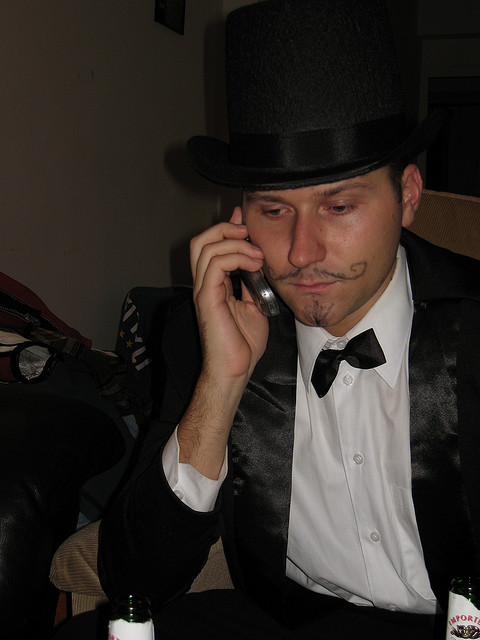What kind of phone is he using?
A. pay
B. rotary
C. landline
D. cellular
Answer with the option's letter from the given choices directly. The individual in the image is using a type of cellular phone, which can be identified by its compact and portable design typical of mobile phones, as compared to the more bulky and static designs of rotary, pay, or landline phones. Hence, the correct answer to the question is option D: cellular. 